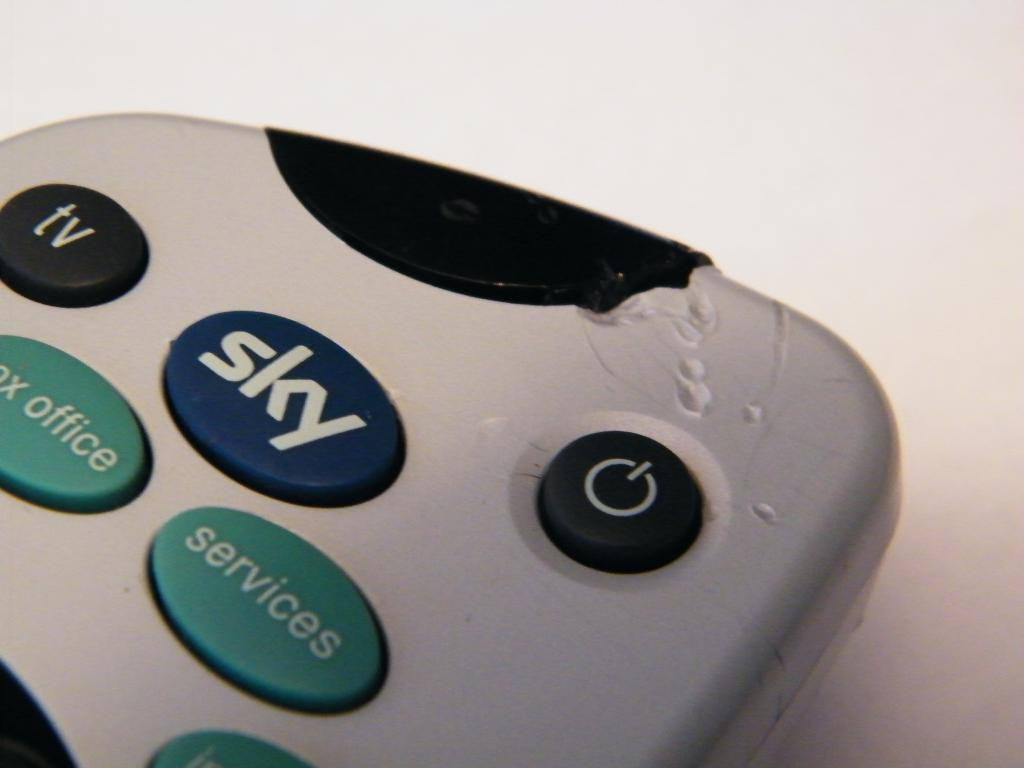<image>
Summarize the visual content of the image. The remote control was chewed on but still worked. 